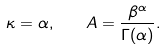<formula> <loc_0><loc_0><loc_500><loc_500>\kappa = \alpha , \quad A = \frac { \beta ^ { \alpha } } { \Gamma ( \alpha ) } .</formula> 